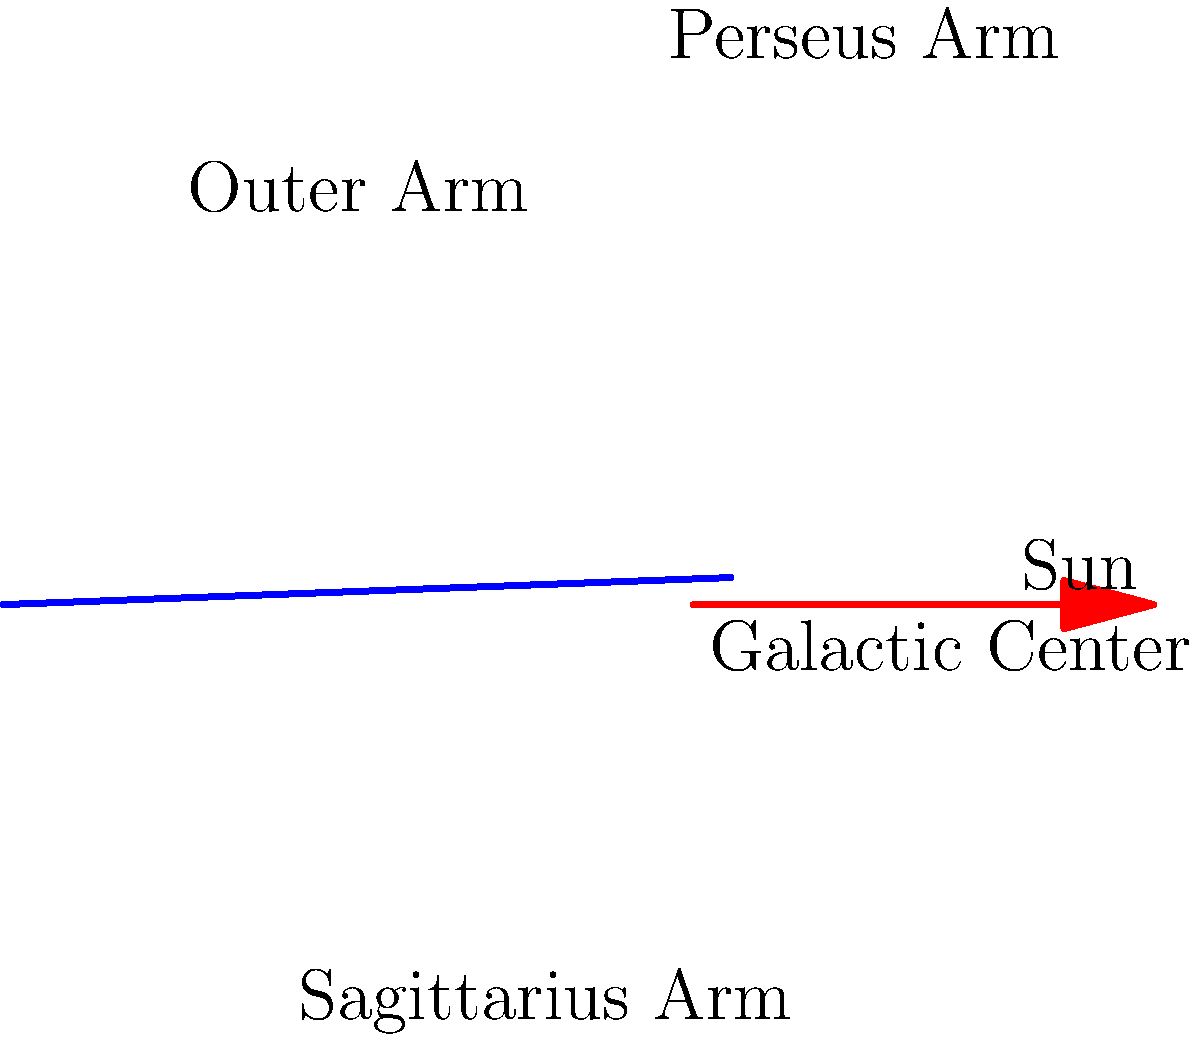As an enthusiastic museum-goer in New York City, you're visiting the American Museum of Natural History's Rose Center for Earth and Space. You come across a diagram of the Milky Way galaxy similar to the one shown above. Based on this spiral representation, approximately how far is the Sun from the Galactic Center in terms of the galaxy's spiral arms? To answer this question, let's analyze the spiral diagram step-by-step:

1. The diagram shows a simplified 2D representation of the Milky Way galaxy's spiral structure.

2. The center of the spiral represents the Galactic Center.

3. The spiral arms are visible, with the Sun's position marked on one of them.

4. Counting from the center outwards, we can identify the following arms:
   a) The innermost arm (not labeled, closest to the Galactic Center)
   b) The Sagittarius Arm
   c) The arm where the Sun is located (sometimes called the Orion Arm or Local Arm)
   d) The Perseus Arm
   e) The Outer Arm

5. The Sun is positioned between the Sagittarius Arm and the Perseus Arm.

6. Counting the arms, we can see that the Sun is located on the third major arm from the Galactic Center.

7. In astronomical terms, this places the Sun approximately 2/3 of the way from the Galactic Center to the outer edge of the galaxy's main spiral structure.

This simplified model helps visualize the Sun's position within the galaxy's structure, although it's important to note that the actual Milky Way is more complex and three-dimensional.
Answer: On the third major arm from the Galactic Center 